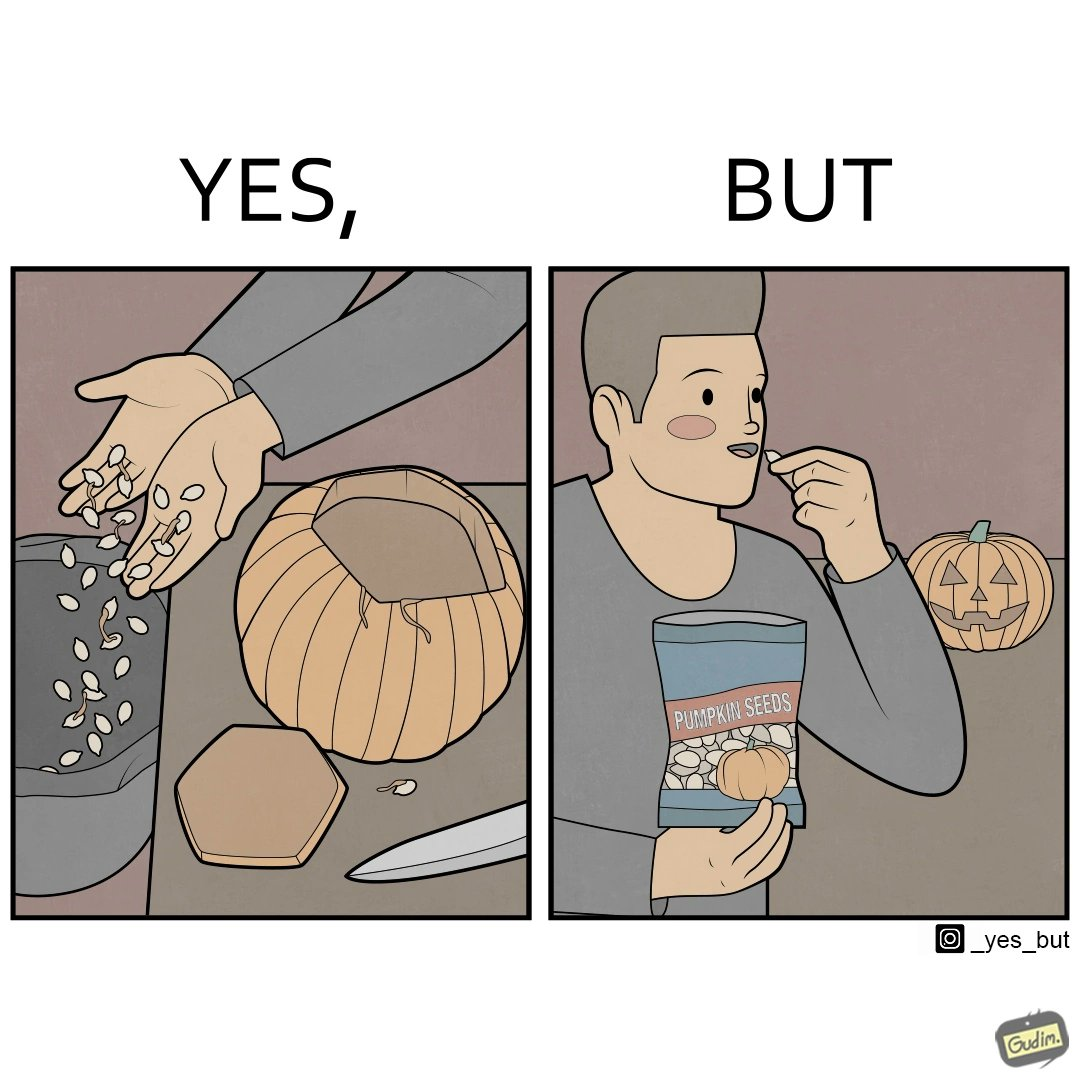Describe what you see in this image. The image is ironic, because on one side the same person throws pumpkin seeds out of pumpkin into dustbin when brought at home but he is eating the package pumpkin seeds 